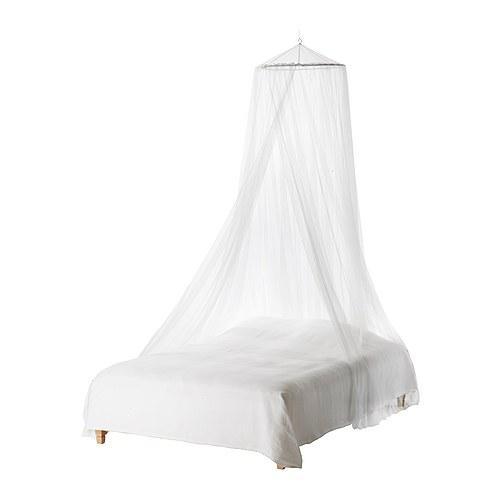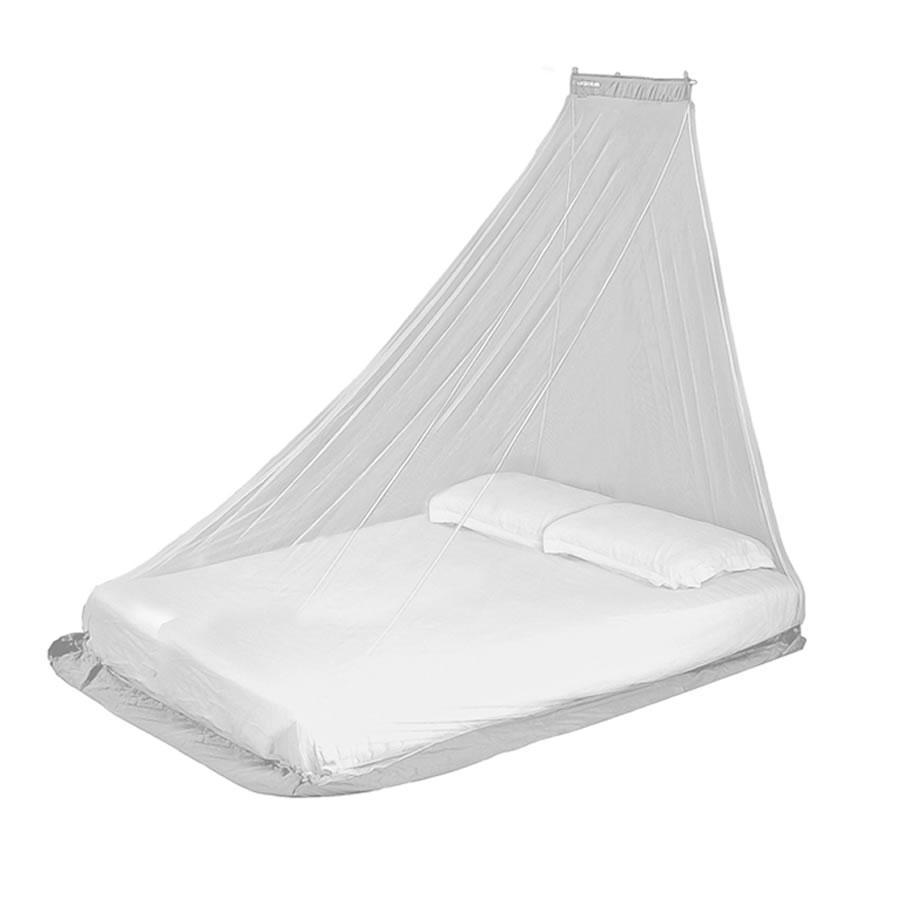The first image is the image on the left, the second image is the image on the right. Given the left and right images, does the statement "There is exactly one pillow on the bed in one of the images." hold true? Answer yes or no. No. 